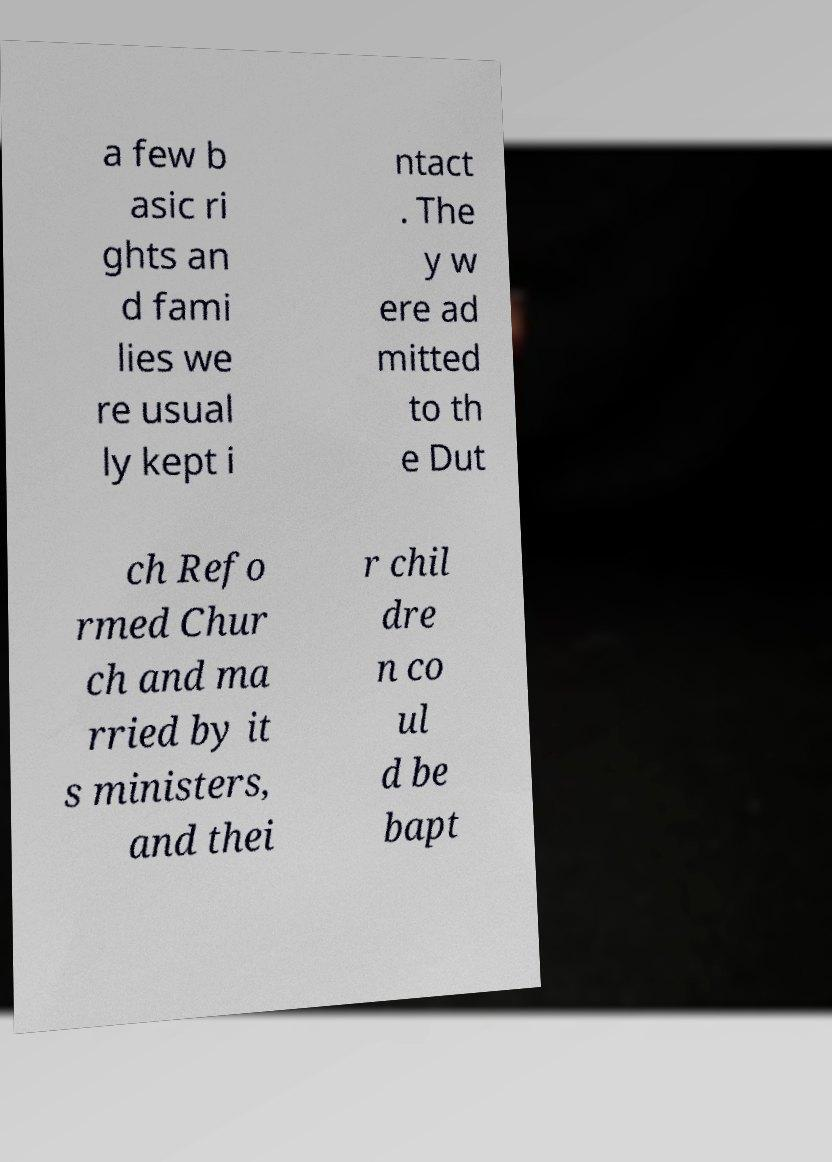I need the written content from this picture converted into text. Can you do that? a few b asic ri ghts an d fami lies we re usual ly kept i ntact . The y w ere ad mitted to th e Dut ch Refo rmed Chur ch and ma rried by it s ministers, and thei r chil dre n co ul d be bapt 